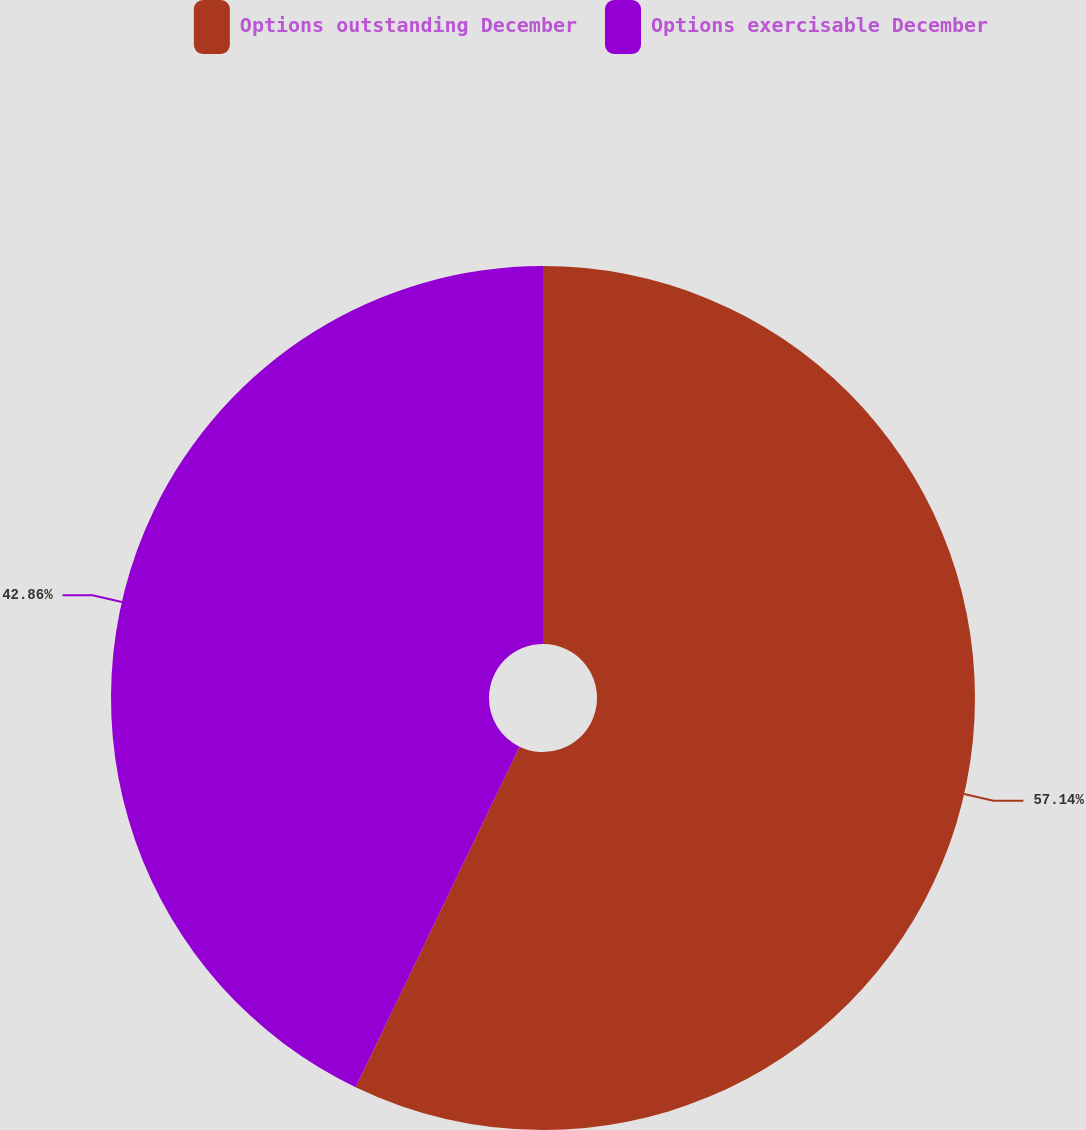<chart> <loc_0><loc_0><loc_500><loc_500><pie_chart><fcel>Options outstanding December<fcel>Options exercisable December<nl><fcel>57.14%<fcel>42.86%<nl></chart> 